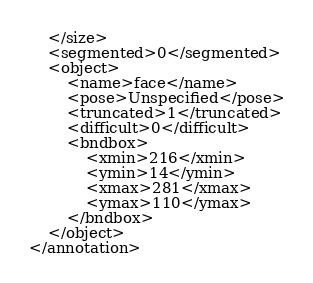<code> <loc_0><loc_0><loc_500><loc_500><_XML_>	</size>
	<segmented>0</segmented>
	<object>
		<name>face</name>
		<pose>Unspecified</pose>
		<truncated>1</truncated>
		<difficult>0</difficult>
		<bndbox>
			<xmin>216</xmin>
			<ymin>14</ymin>
			<xmax>281</xmax>
			<ymax>110</ymax>
		</bndbox>
	</object>
</annotation></code> 